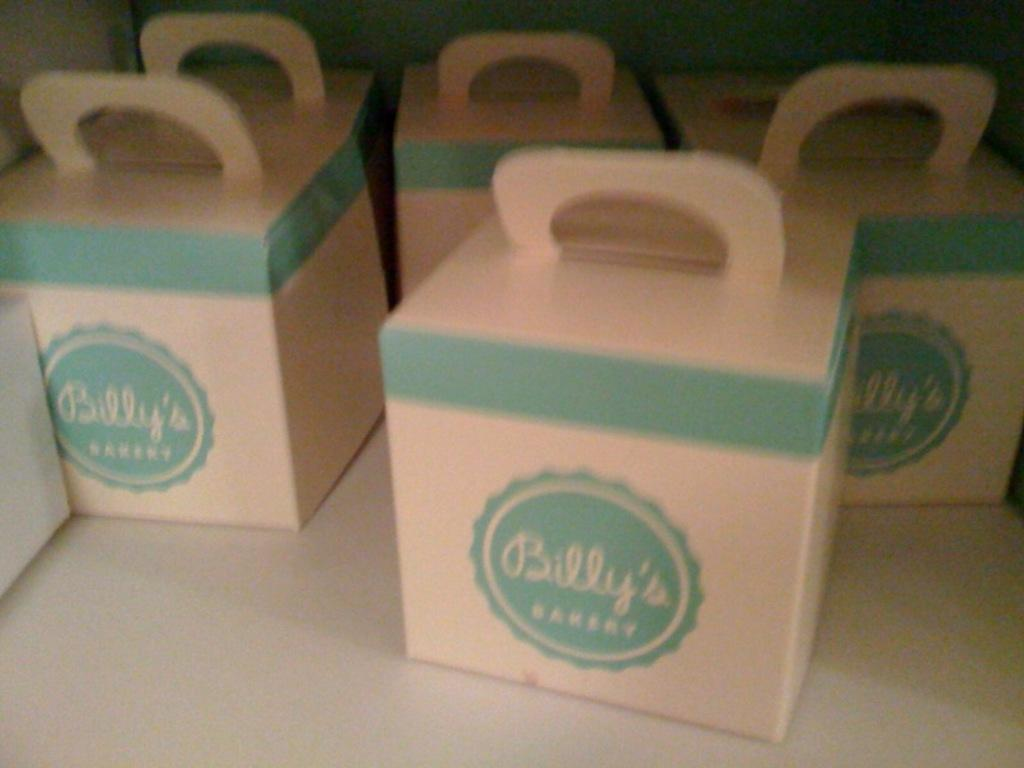Provide a one-sentence caption for the provided image. Containers from Billy's Bakery sitting by each other. 